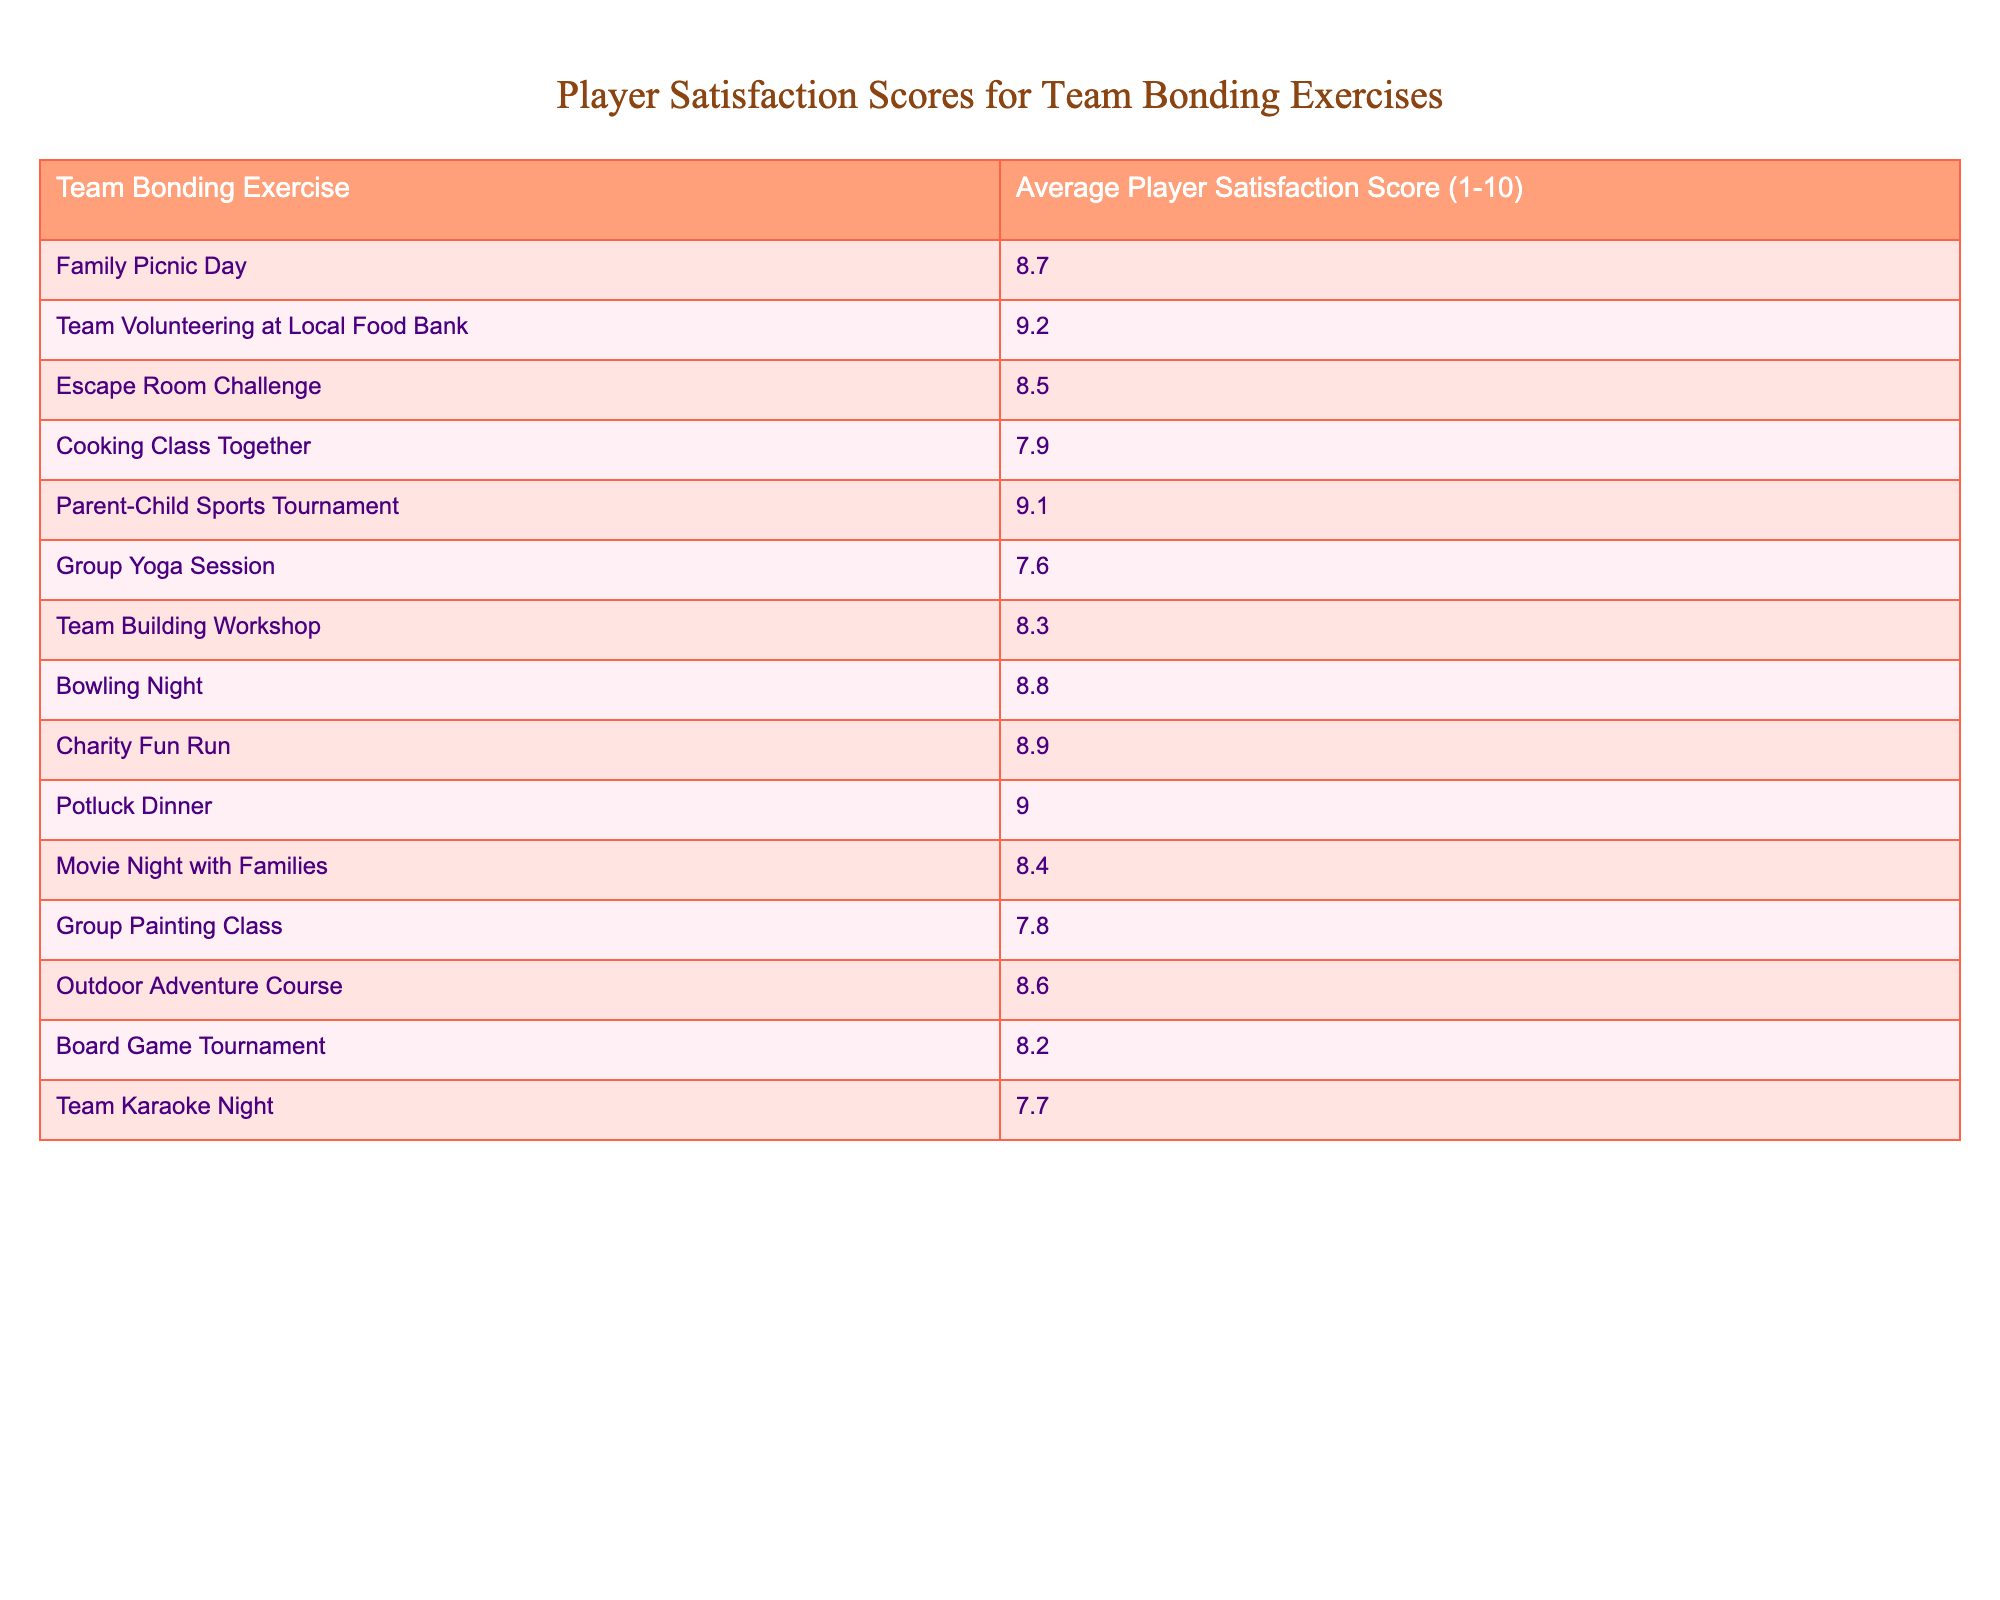What is the highest player satisfaction score? The table shows that the highest satisfaction score is 9.2 for the "Team Volunteering at Local Food Bank" exercise.
Answer: 9.2 Which team bonding exercise received a satisfaction score of 7.6? According to the table, the "Group Yoga Session" received a satisfaction score of 7.6.
Answer: Group Yoga Session What is the average satisfaction score for all team bonding exercises listed? To calculate the average, sum all the scores (8.7 + 9.2 + 8.5 + 7.9 + 9.1 + 7.6 + 8.3 + 8.8 + 8.9 + 9.0 + 8.4 + 7.8 + 8.6 + 8.2 + 7.7 = 131.6) and divide by the number of exercises (15), which gives 131.6 / 15 ≈ 8.77.
Answer: Approximately 8.77 Is "Cooking Class Together" rated higher than "Escape Room Challenge"? The score for "Cooking Class Together" is 7.9, and the score for "Escape Room Challenge" is 8.5, so "Cooking Class Together" is rated lower.
Answer: No What are the two exercises with the closest satisfaction scores? Looking at the scores, "Escape Room Challenge" (8.5) and "Cooking Class Together" (7.9) have relatively closer scores compared to others, but "Team Building Workshop" (8.3) is closer to both as well. However, "Team Building Workshop" and "Bowling Night" (8.8) are also close but more so to "Escape Room." The closest pair are "Team Building Workshop" and "Escape Room Challenge."
Answer: "Team Building Workshop" and "Escape Room Challenge" How many exercises have satisfaction scores above 8.5? From the table, by counting scores above 8.5: "Team Volunteering at Local Food Bank" (9.2), "Parent-Child Sports Tournament" (9.1), "Charity Fun Run" (8.9), "Potluck Dinner" (9.0), "Bowling Night" (8.8). This is a total of 5 exercises.
Answer: 5 Which exercise has the lowest satisfaction score? By checking the table, the "Group Yoga Session" has the lowest satisfaction score at 7.6.
Answer: Group Yoga Session Which two exercises combined have a satisfaction score total of 17.3? Adding the satisfaction scores of "Cooking Class Together" (7.9) and "Escape Room Challenge" (8.5) gives 7.9 + 8.5 = 16.4, while "Team Karaoke Night" (7.7) and "Group Painting Class" (7.8) give 7.7 + 7.8 = 15.5. None combine to 17.3, suggesting no such pair directly exists.
Answer: None Are there more exercises that scored under 8 than those over 8? There are 7 exercises that scored under 8 (Cooking Class, Group Yoga, Group Painting, Team Karaoke) and 8 exercises over 8. Therefore, there are more exercises over 8.
Answer: Yes 